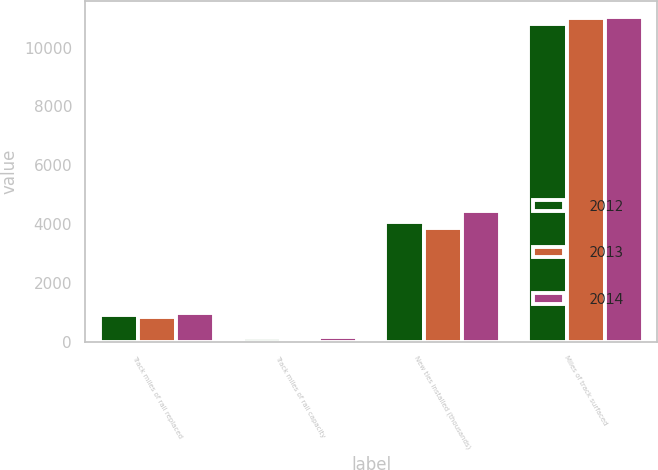Convert chart to OTSL. <chart><loc_0><loc_0><loc_500><loc_500><stacked_bar_chart><ecel><fcel>Track miles of rail replaced<fcel>Track miles of rail capacity<fcel>New ties installed (thousands)<fcel>Miles of track surfaced<nl><fcel>2012<fcel>912<fcel>119<fcel>4076<fcel>10791<nl><fcel>2013<fcel>834<fcel>97<fcel>3870<fcel>11017<nl><fcel>2014<fcel>964<fcel>139<fcel>4436<fcel>11049<nl></chart> 